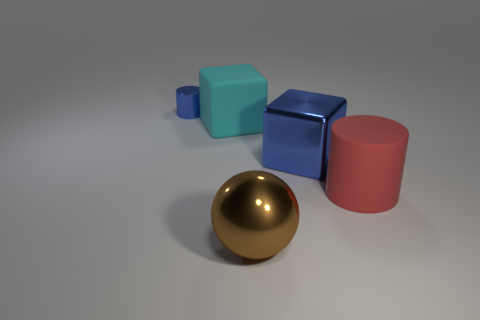Add 4 tiny gray metal cylinders. How many objects exist? 9 Subtract all spheres. How many objects are left? 4 Subtract all cyan blocks. How many blocks are left? 1 Subtract all metal cubes. Subtract all small yellow matte cylinders. How many objects are left? 4 Add 4 brown spheres. How many brown spheres are left? 5 Add 4 red matte cylinders. How many red matte cylinders exist? 5 Subtract 1 brown balls. How many objects are left? 4 Subtract 1 blocks. How many blocks are left? 1 Subtract all red spheres. Subtract all yellow blocks. How many spheres are left? 1 